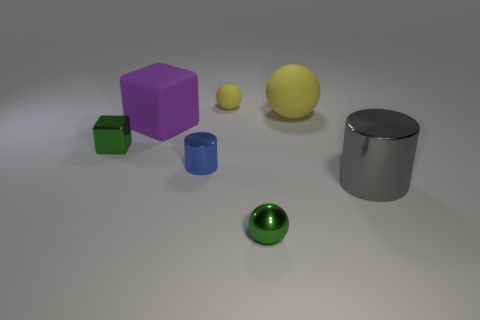Subtract 1 balls. How many balls are left? 2 Add 2 small blue objects. How many objects exist? 9 Subtract all spheres. How many objects are left? 4 Subtract all gray things. Subtract all large purple blocks. How many objects are left? 5 Add 6 green shiny objects. How many green shiny objects are left? 8 Add 3 green metal things. How many green metal things exist? 5 Subtract 0 cyan cylinders. How many objects are left? 7 